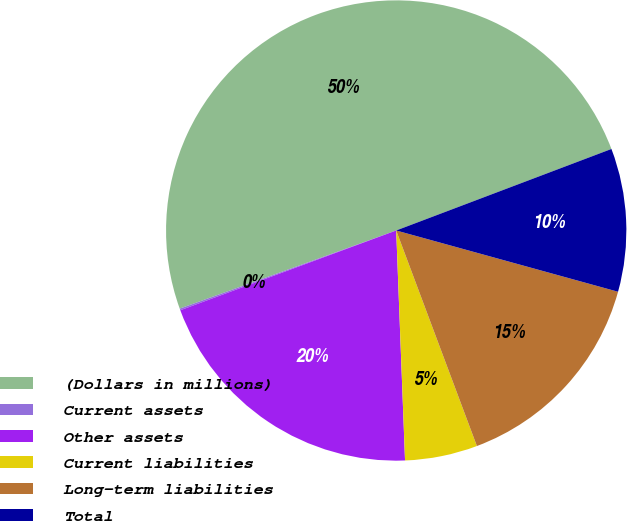Convert chart to OTSL. <chart><loc_0><loc_0><loc_500><loc_500><pie_chart><fcel>(Dollars in millions)<fcel>Current assets<fcel>Other assets<fcel>Current liabilities<fcel>Long-term liabilities<fcel>Total<nl><fcel>49.75%<fcel>0.12%<fcel>19.98%<fcel>5.09%<fcel>15.01%<fcel>10.05%<nl></chart> 